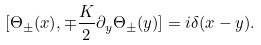<formula> <loc_0><loc_0><loc_500><loc_500>[ \Theta _ { \pm } ( x ) , \mp \frac { K } { 2 } \partial _ { y } \Theta _ { \pm } ( y ) ] = i \delta ( x - y ) .</formula> 